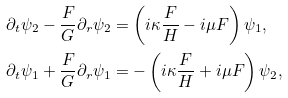Convert formula to latex. <formula><loc_0><loc_0><loc_500><loc_500>\partial _ { t } \psi _ { 2 } - \frac { F } { G } \partial _ { r } \psi _ { 2 } & = \left ( i \kappa \frac { F } { H } - i \mu F \right ) \psi _ { 1 } , \\ \partial _ { t } \psi _ { 1 } + \frac { F } { G } \partial _ { r } \psi _ { 1 } & = - \left ( i \kappa \frac { F } { H } + i \mu F \right ) \psi _ { 2 } ,</formula> 